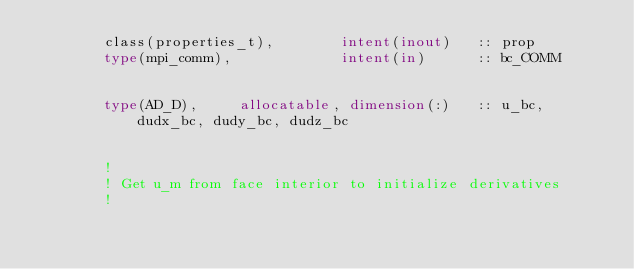Convert code to text. <code><loc_0><loc_0><loc_500><loc_500><_FORTRAN_>        class(properties_t),        intent(inout)   :: prop
        type(mpi_comm),             intent(in)      :: bc_COMM


        type(AD_D),     allocatable, dimension(:)   :: u_bc, dudx_bc, dudy_bc, dudz_bc


        !
        ! Get u_m from face interior to initialize derivatives
        !</code> 